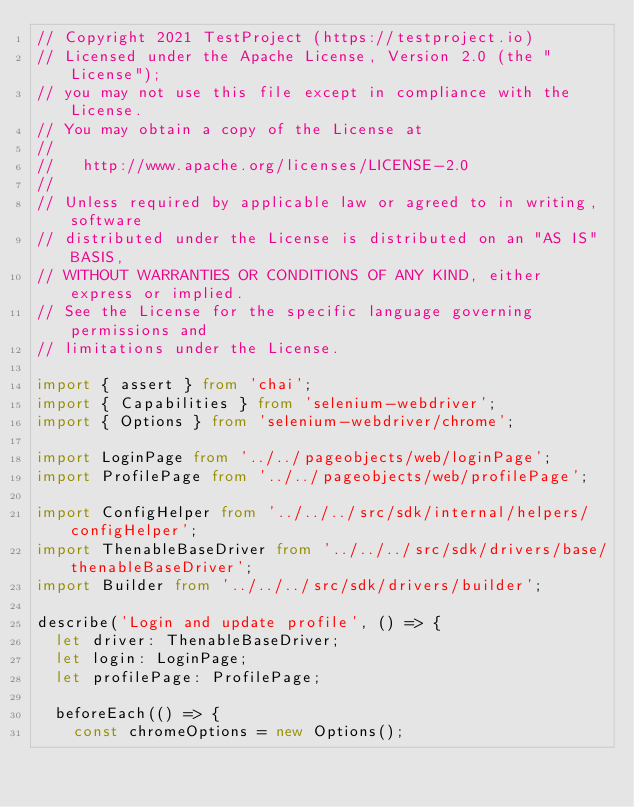Convert code to text. <code><loc_0><loc_0><loc_500><loc_500><_TypeScript_>// Copyright 2021 TestProject (https://testproject.io)
// Licensed under the Apache License, Version 2.0 (the "License");
// you may not use this file except in compliance with the License.
// You may obtain a copy of the License at
//
//   http://www.apache.org/licenses/LICENSE-2.0
//
// Unless required by applicable law or agreed to in writing, software
// distributed under the License is distributed on an "AS IS" BASIS,
// WITHOUT WARRANTIES OR CONDITIONS OF ANY KIND, either express or implied.
// See the License for the specific language governing permissions and
// limitations under the License.

import { assert } from 'chai';
import { Capabilities } from 'selenium-webdriver';
import { Options } from 'selenium-webdriver/chrome';

import LoginPage from '../../pageobjects/web/loginPage';
import ProfilePage from '../../pageobjects/web/profilePage';

import ConfigHelper from '../../../src/sdk/internal/helpers/configHelper';
import ThenableBaseDriver from '../../../src/sdk/drivers/base/thenableBaseDriver';
import Builder from '../../../src/sdk/drivers/builder';

describe('Login and update profile', () => {
  let driver: ThenableBaseDriver;
  let login: LoginPage;
  let profilePage: ProfilePage;

  beforeEach(() => {
    const chromeOptions = new Options();</code> 